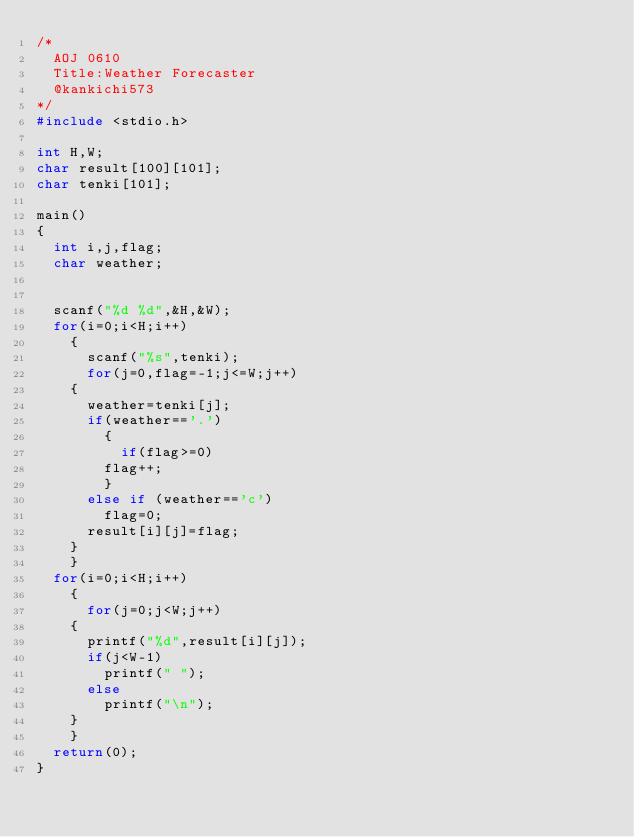<code> <loc_0><loc_0><loc_500><loc_500><_C_>/*
  AOJ 0610
  Title:Weather Forecaster
  @kankichi573
*/
#include <stdio.h>

int H,W;
char result[100][101];
char tenki[101];

main()
{
  int i,j,flag;
  char weather;
  

  scanf("%d %d",&H,&W);
  for(i=0;i<H;i++)
    {
      scanf("%s",tenki);
      for(j=0,flag=-1;j<=W;j++)
	{
	  weather=tenki[j];
	  if(weather=='.')
	    {
	      if(flag>=0)
		flag++;
	    }
	  else if (weather=='c')
	    flag=0;
	  result[i][j]=flag;
	}
    }
  for(i=0;i<H;i++)
    {
      for(j=0;j<W;j++)
	{
	  printf("%d",result[i][j]);
	  if(j<W-1)
	    printf(" ");
	  else
	    printf("\n");
	}
    }
  return(0);
}</code> 